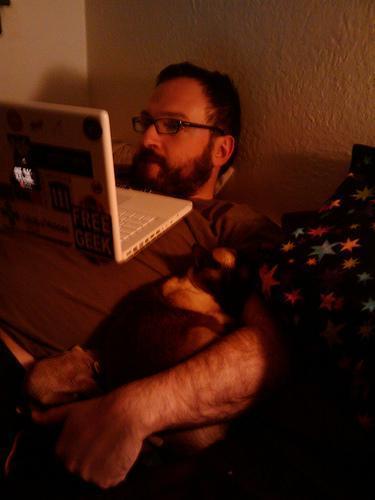How many people are picture?
Give a very brief answer. 1. 